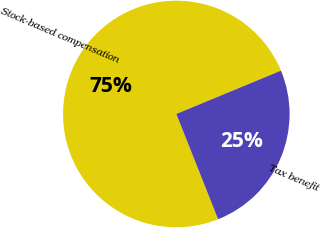Convert chart. <chart><loc_0><loc_0><loc_500><loc_500><pie_chart><fcel>Stock-based compensation<fcel>Tax benefit<nl><fcel>74.77%<fcel>25.23%<nl></chart> 